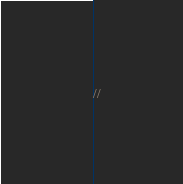Convert code to text. <code><loc_0><loc_0><loc_500><loc_500><_C++_>//</code> 